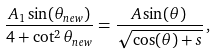<formula> <loc_0><loc_0><loc_500><loc_500>\frac { A _ { 1 } \sin ( \theta _ { n e w } ) } { 4 + \cot ^ { 2 } \theta _ { n e w } } = \frac { A \sin ( \theta ) } { \sqrt { \cos ( \theta ) + s } } \, ,</formula> 